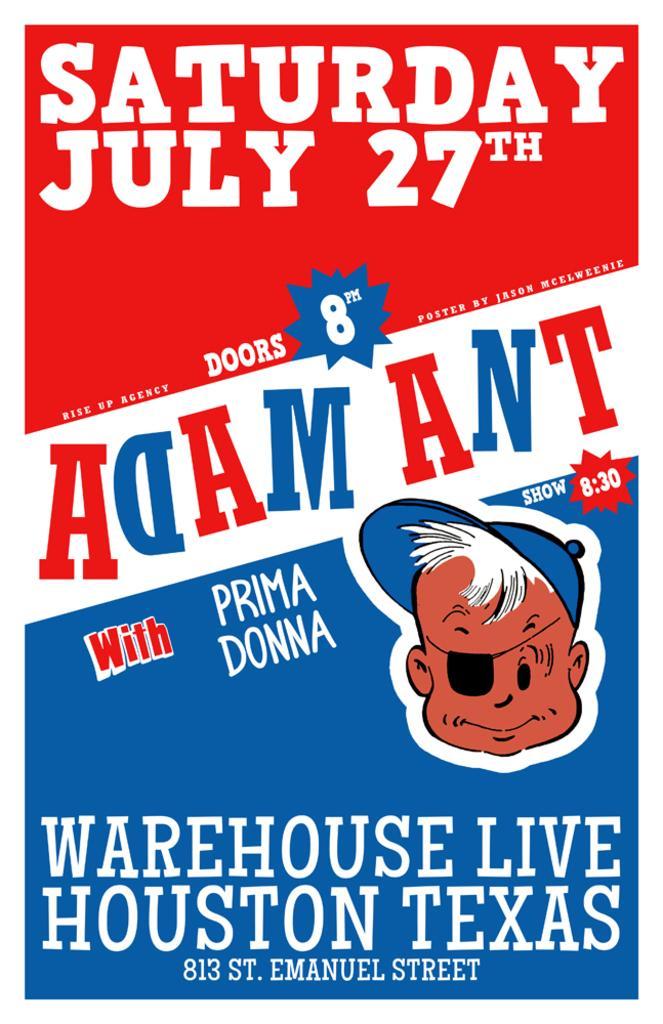How would you summarize this image in a sentence or two? This picture is consists of a poster in the image. 